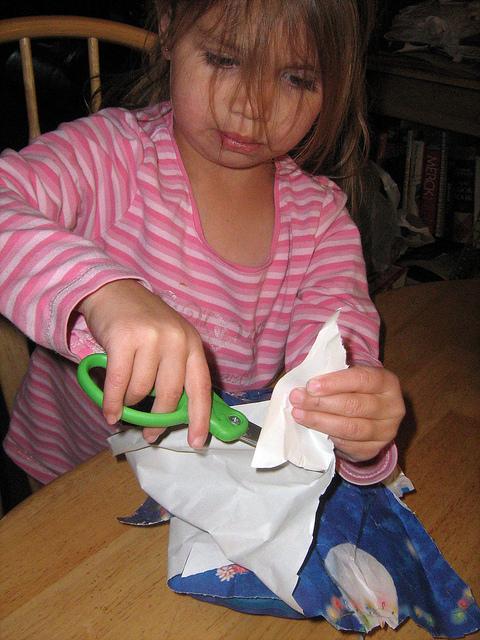What other object is in the picture?
Write a very short answer. Scissors. Is this person happy or sad?
Give a very brief answer. Sad. What is in the girls hand?
Write a very short answer. Scissors. How many languages do you think this child can write?
Keep it brief. 1. What is in her hand?
Give a very brief answer. Scissors. What color is the little girl's shirt?
Give a very brief answer. Pink. What is the pattern on her shirt?
Short answer required. Stripes. Is he playing with scissors?
Answer briefly. Yes. What is the young girl holding in her right hand?
Quick response, please. Scissors. What is the girl using to cut the paper?
Give a very brief answer. Scissors. Can this baby name all of the colors of her shirt?
Short answer required. Yes. Is it daytime in this picture?
Quick response, please. No. What is this person holding?
Give a very brief answer. Scissors. Is the girl cutting her hair?
Quick response, please. No. What is this kid doing?
Keep it brief. Cutting. What is the person cutting?
Concise answer only. Paper. 